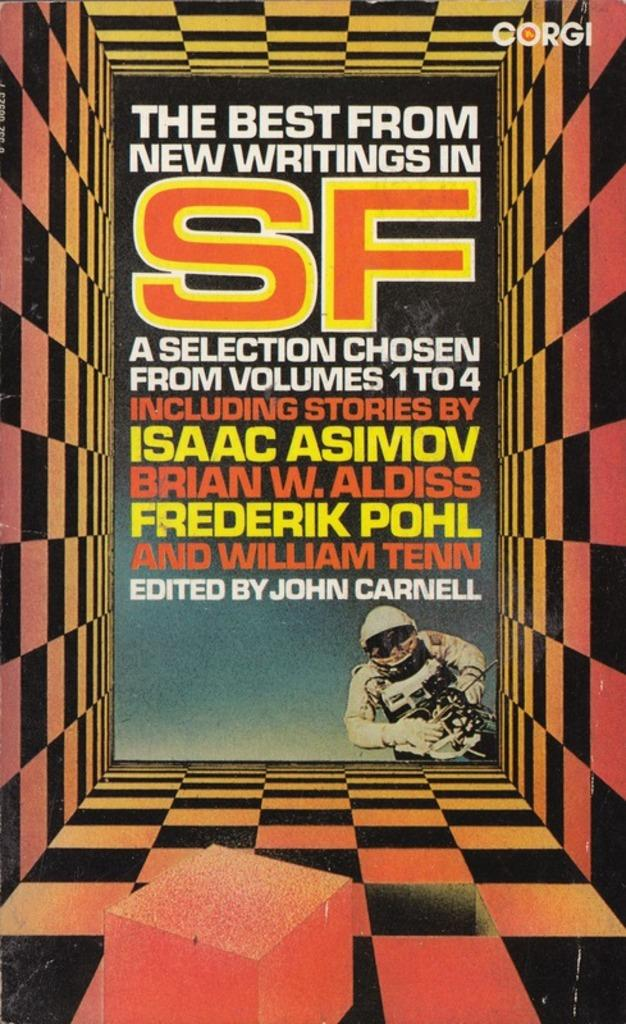Provide a one-sentence caption for the provided image. A book of new writings from science fiction including  Isaac Asimov. 